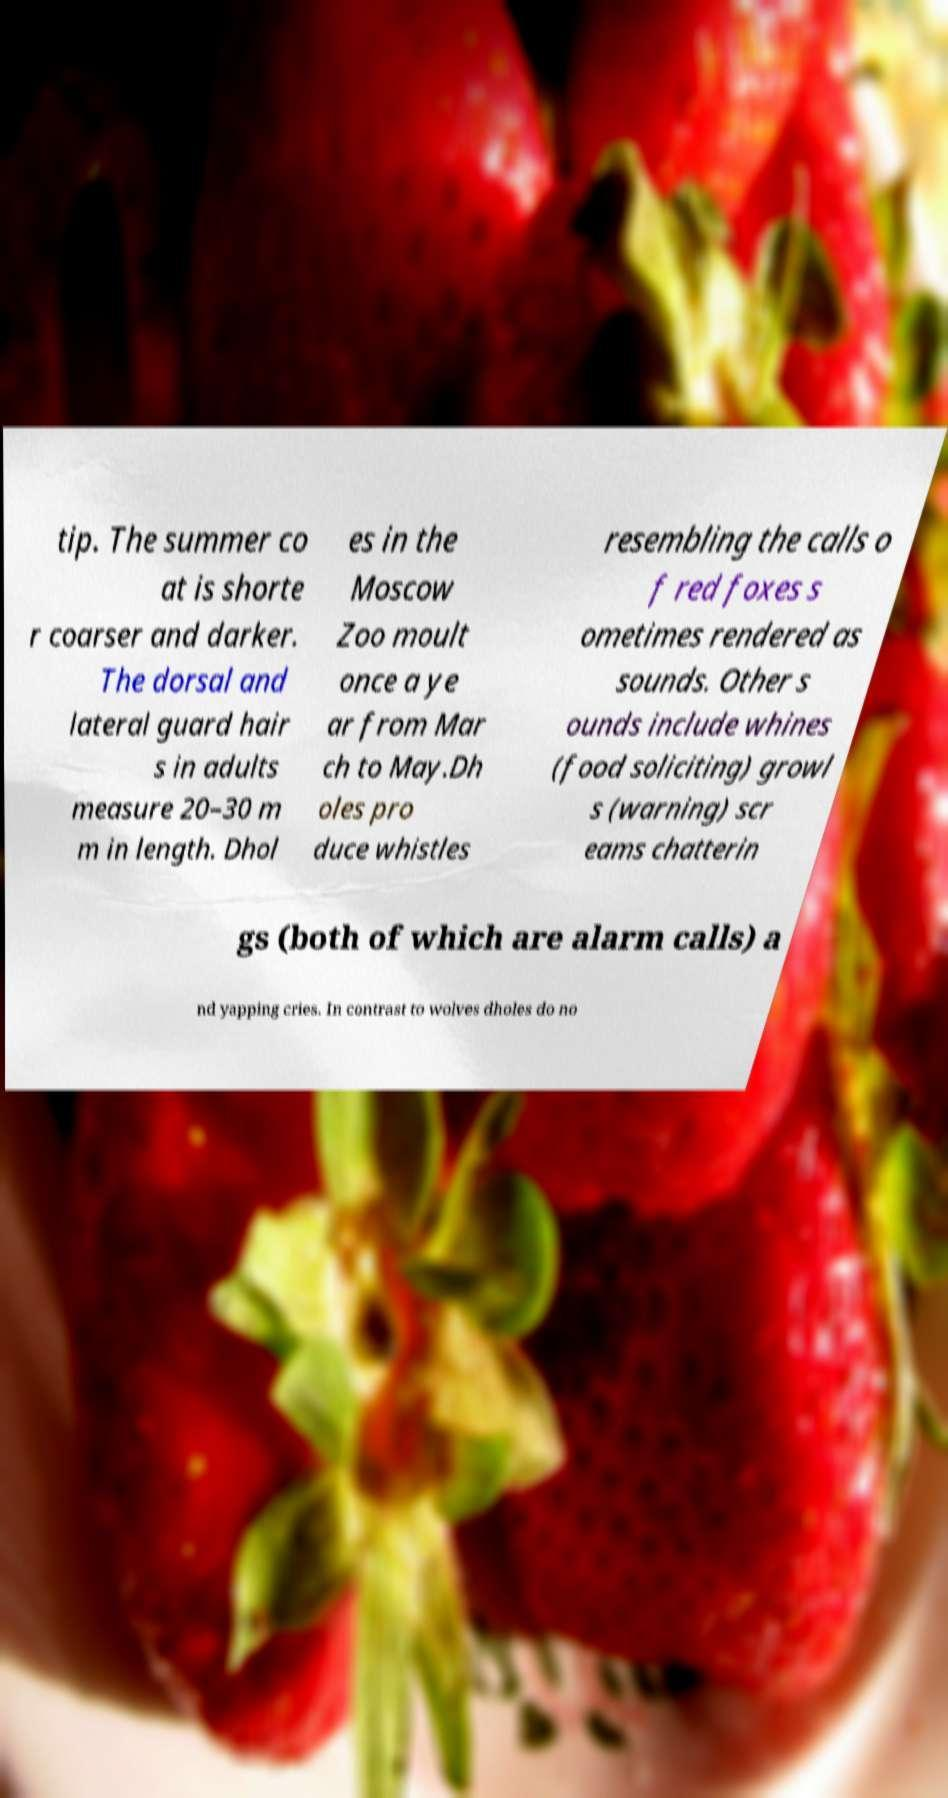I need the written content from this picture converted into text. Can you do that? tip. The summer co at is shorte r coarser and darker. The dorsal and lateral guard hair s in adults measure 20–30 m m in length. Dhol es in the Moscow Zoo moult once a ye ar from Mar ch to May.Dh oles pro duce whistles resembling the calls o f red foxes s ometimes rendered as sounds. Other s ounds include whines (food soliciting) growl s (warning) scr eams chatterin gs (both of which are alarm calls) a nd yapping cries. In contrast to wolves dholes do no 